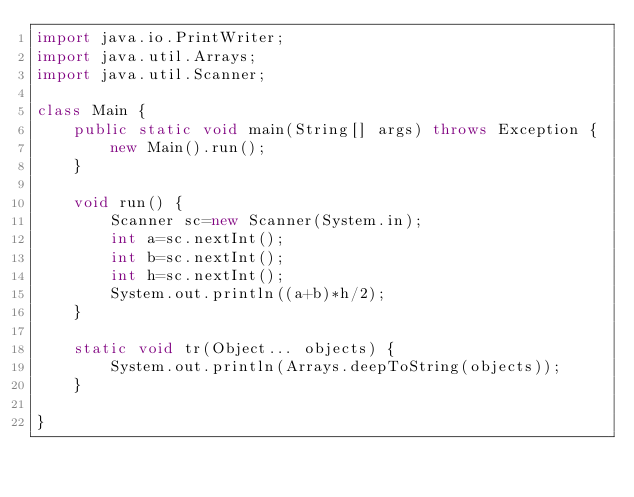<code> <loc_0><loc_0><loc_500><loc_500><_Java_>import java.io.PrintWriter;
import java.util.Arrays;
import java.util.Scanner;

class Main {
	public static void main(String[] args) throws Exception {
		new Main().run();
	}
	
	void run() {
		Scanner sc=new Scanner(System.in);
		int a=sc.nextInt();
		int b=sc.nextInt();
		int h=sc.nextInt();
		System.out.println((a+b)*h/2);
	}
	
	static void tr(Object... objects) {
		System.out.println(Arrays.deepToString(objects));
	}
	
}
</code> 